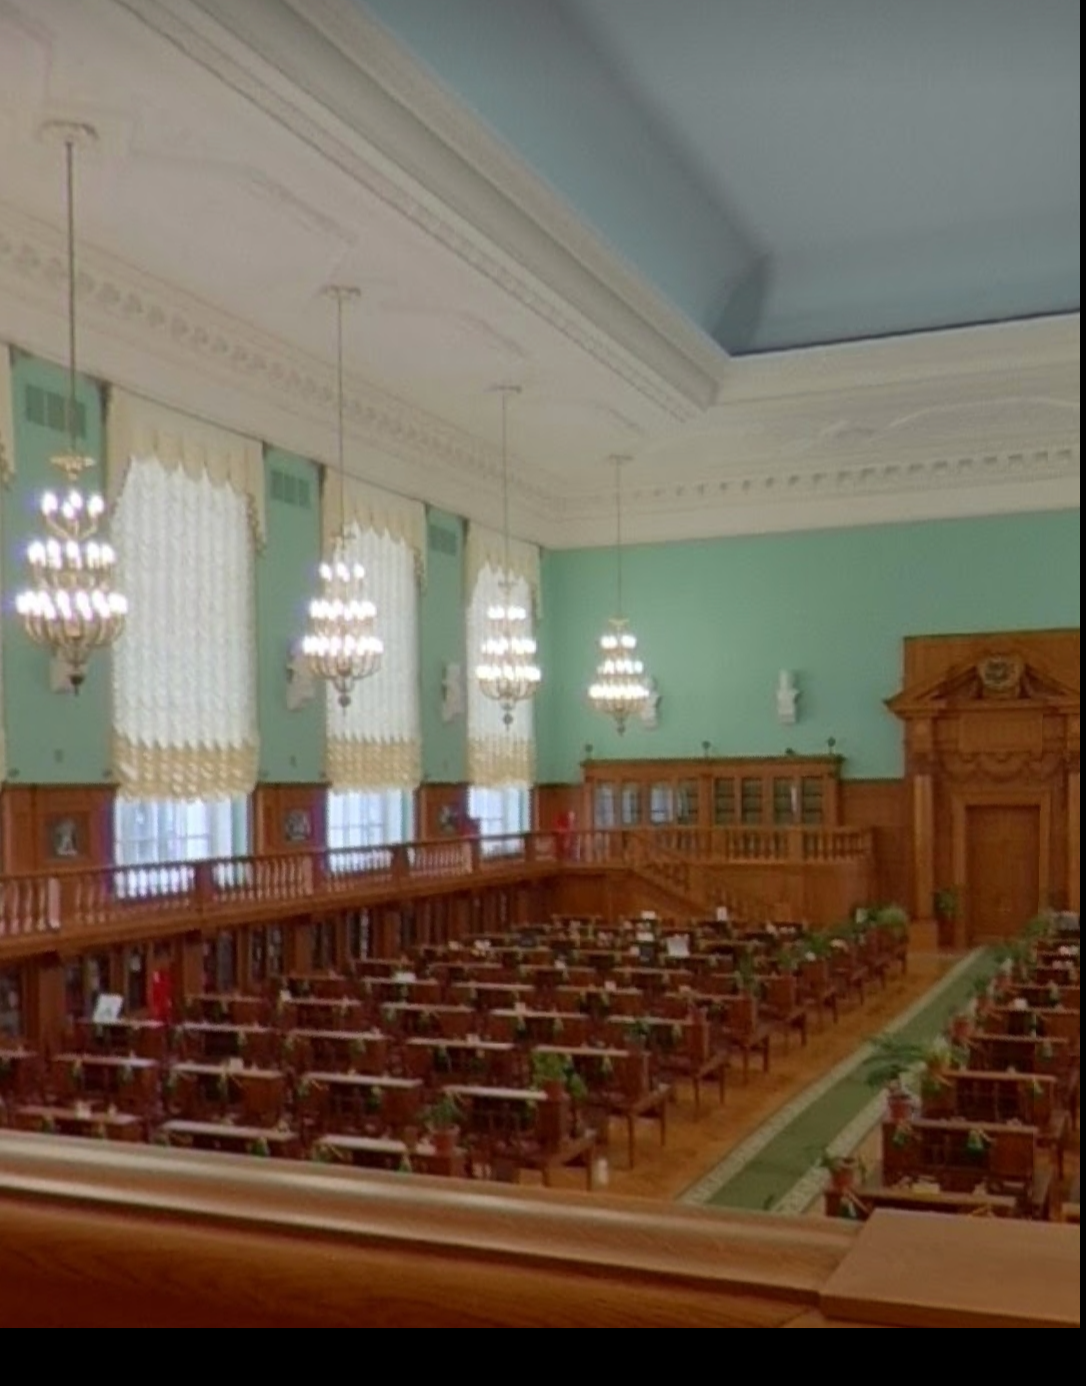Determine where this photo was taken (guess as close as you can) The photo was taken in the Russian State Library in Moscow, Russia. 